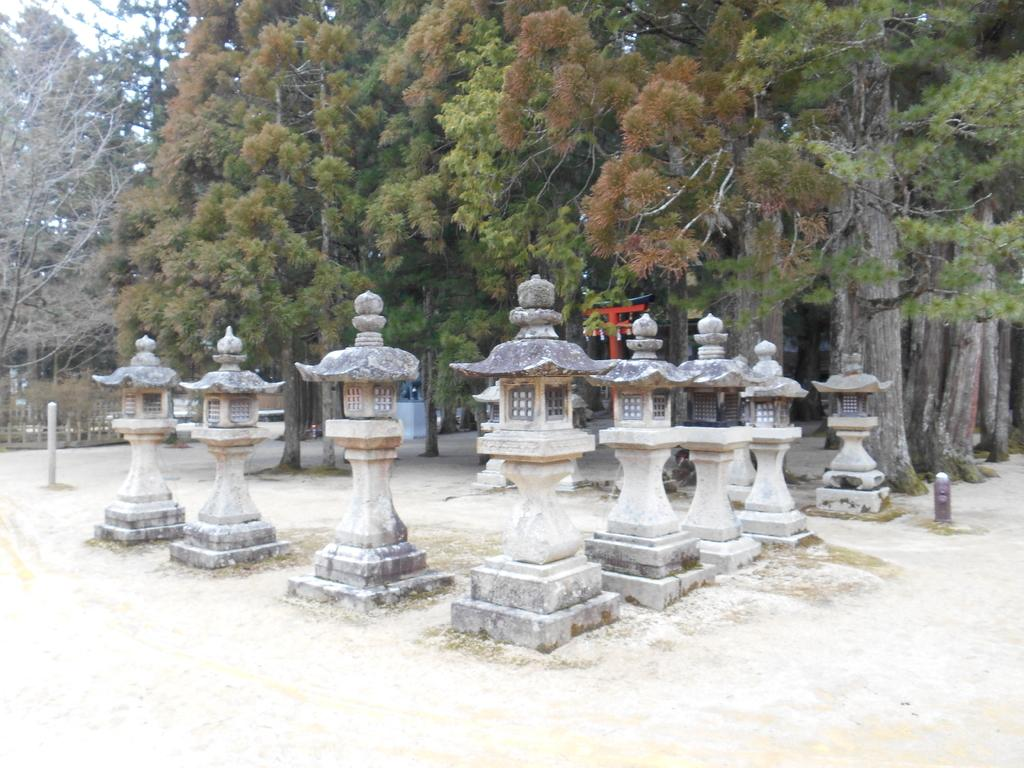What architectural elements can be seen in the image? There are pillars in the image. What type of vegetation is present in the image? There are trees with green color in the image. How would you describe the sky in the image? The sky appears to be white in the image. What type of sweater is hanging on the tree in the image? There is no sweater present in the image; it features pillars, trees, and a white sky. How many cherries can be seen on the pillars in the image? There are no cherries present in the image; it only features pillars, trees, and a white sky. 